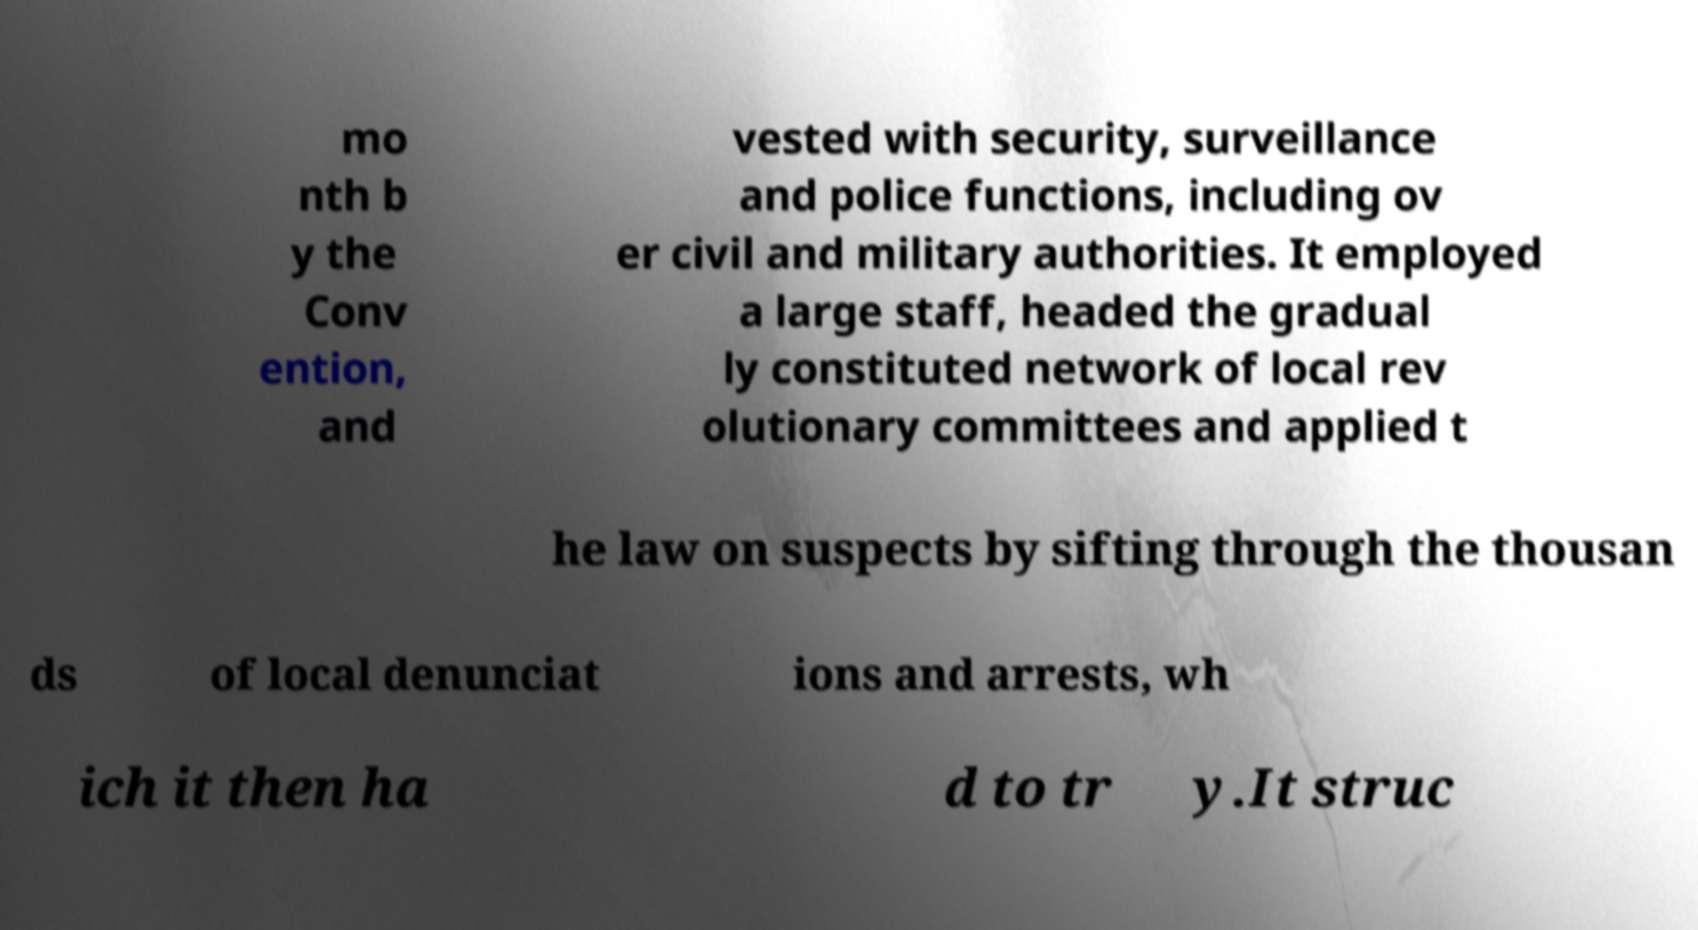There's text embedded in this image that I need extracted. Can you transcribe it verbatim? mo nth b y the Conv ention, and vested with security, surveillance and police functions, including ov er civil and military authorities. It employed a large staff, headed the gradual ly constituted network of local rev olutionary committees and applied t he law on suspects by sifting through the thousan ds of local denunciat ions and arrests, wh ich it then ha d to tr y.It struc 